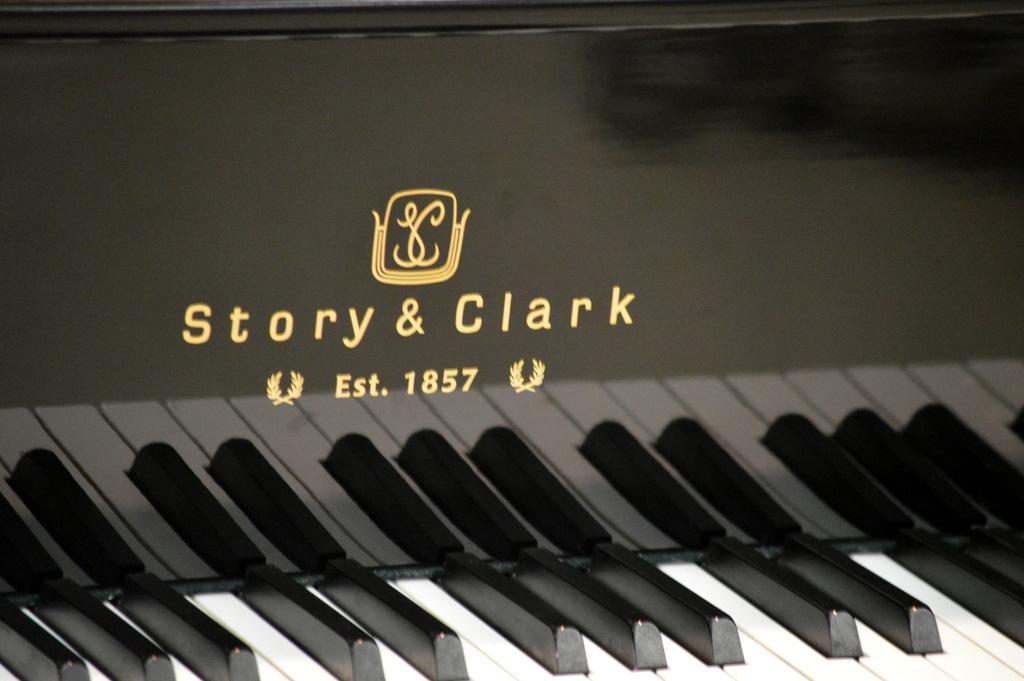Could you give a brief overview of what you see in this image? As we can see in the image there is a black and white color musical keyboard and here it was written as "story and Clark" 